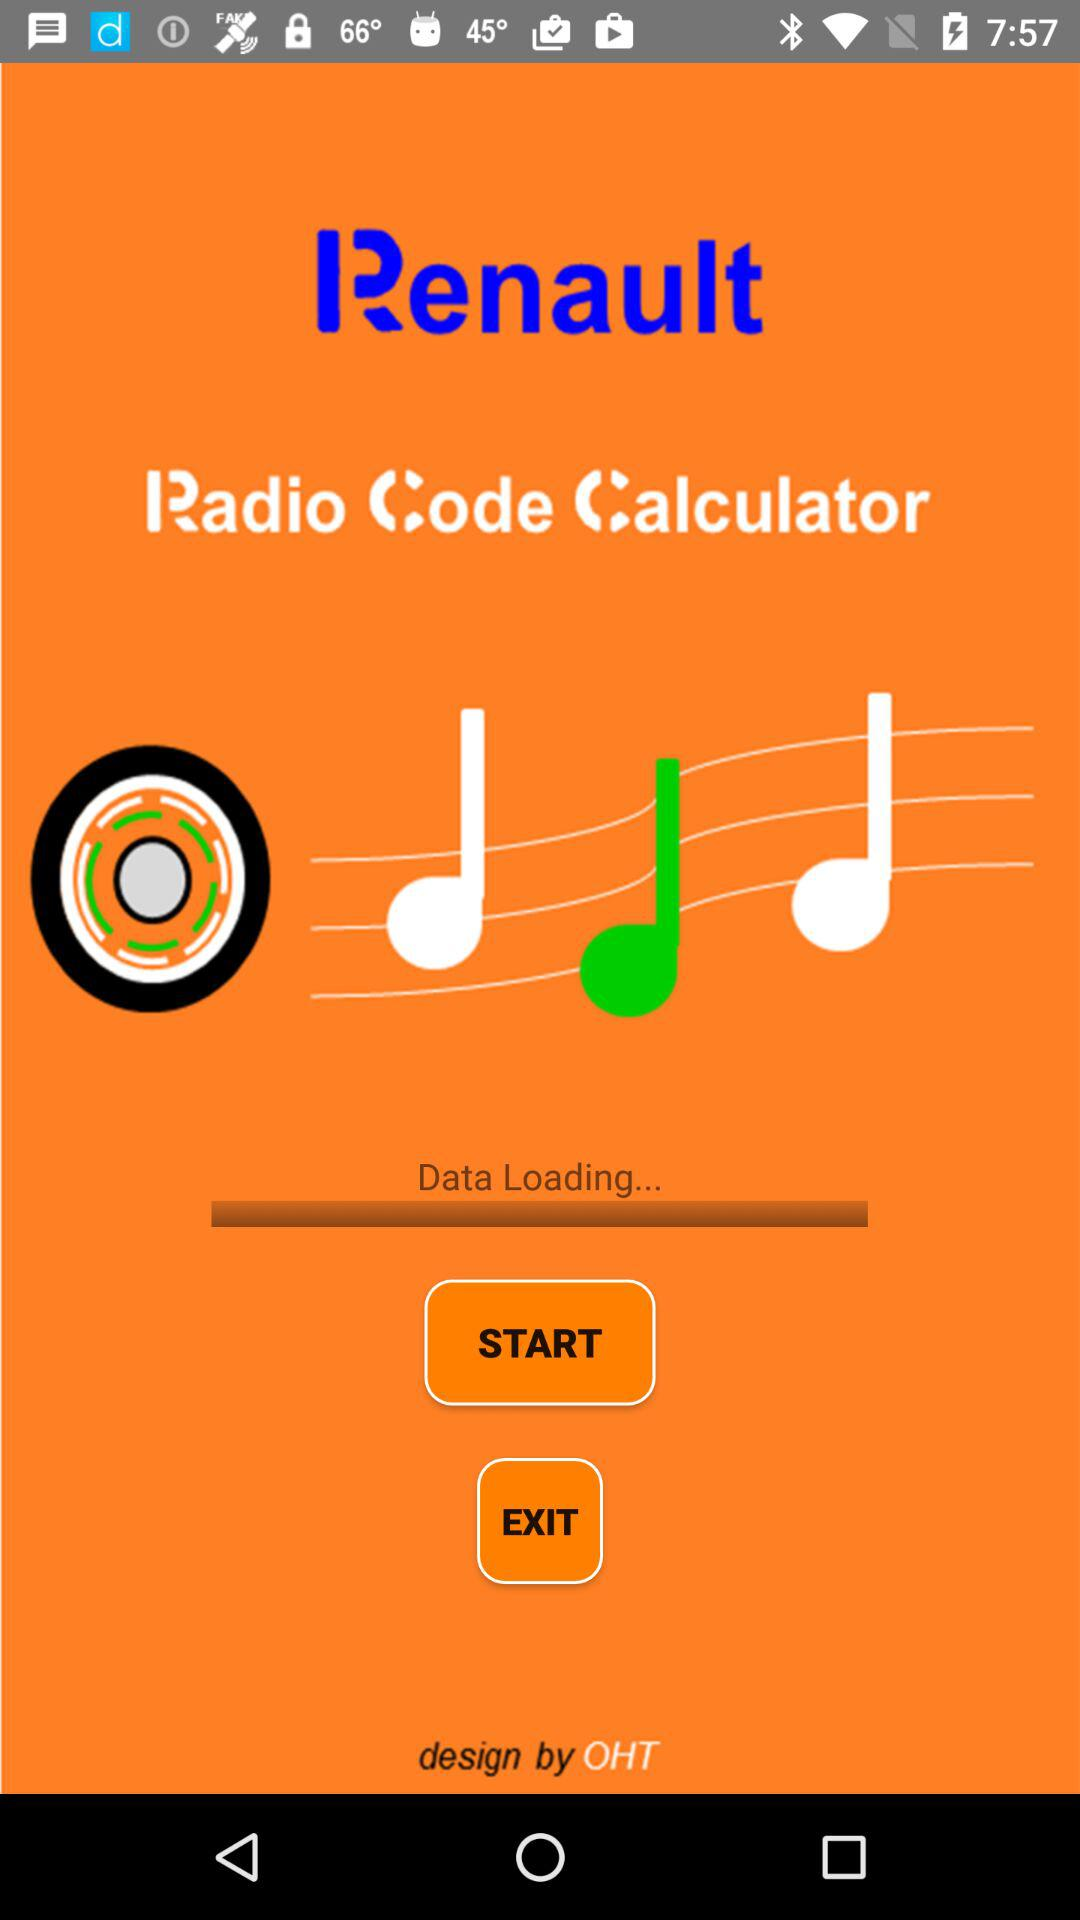What is the name of the application? The name of the application is "Renault Radio Code Calculator". 